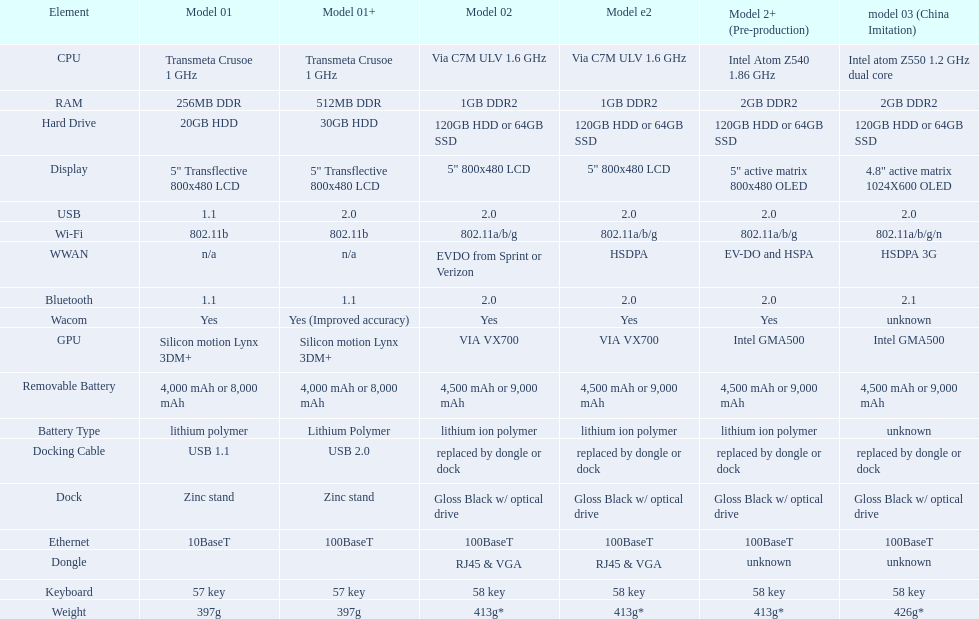After bluetooth, what component is next? Wacom. 